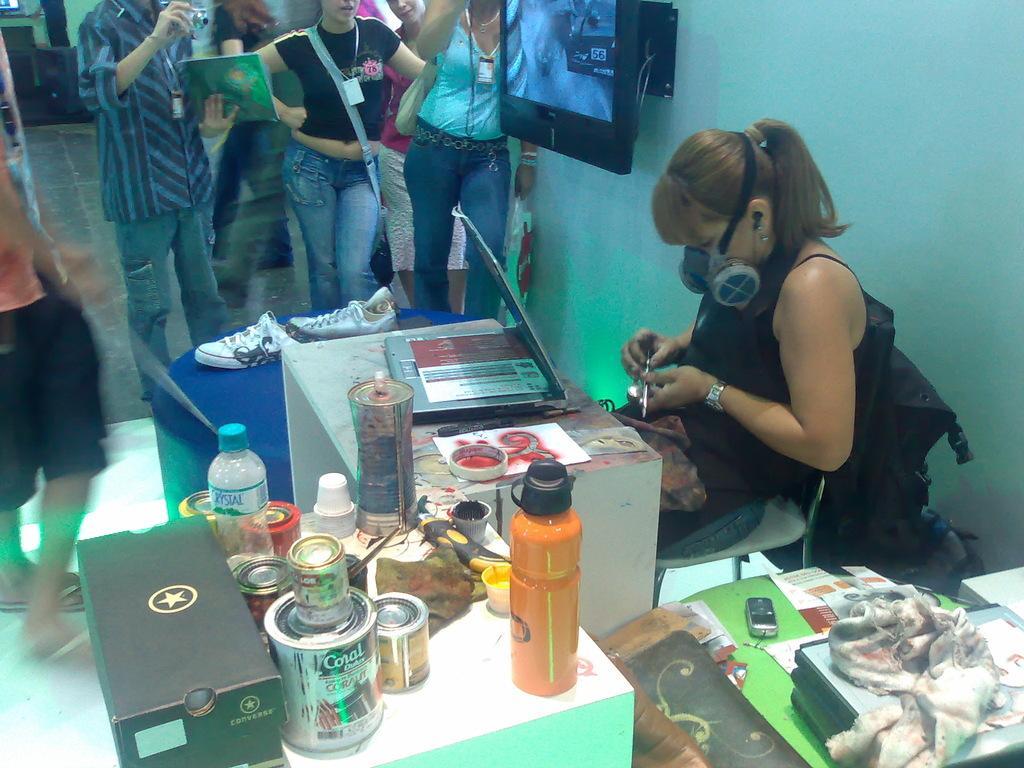In one or two sentences, can you explain what this image depicts? a person is sitting, holding a object in her hand. in front of her there is a table on which there are paper, tape, bottle, tins and shoes. behind her people are standing and there is a screen on the wall. 